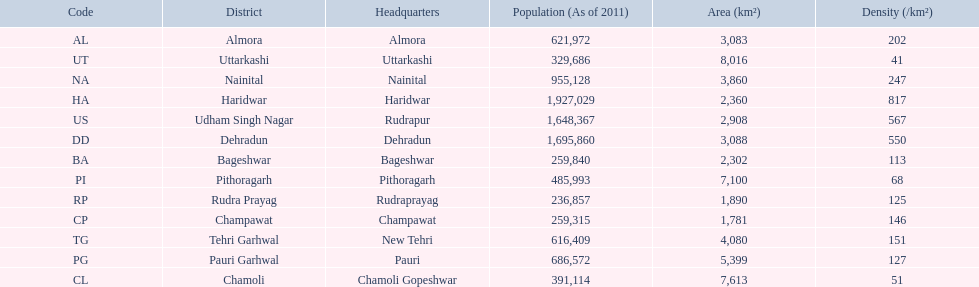If a person was headquartered in almora what would be his/her district? Almora. 